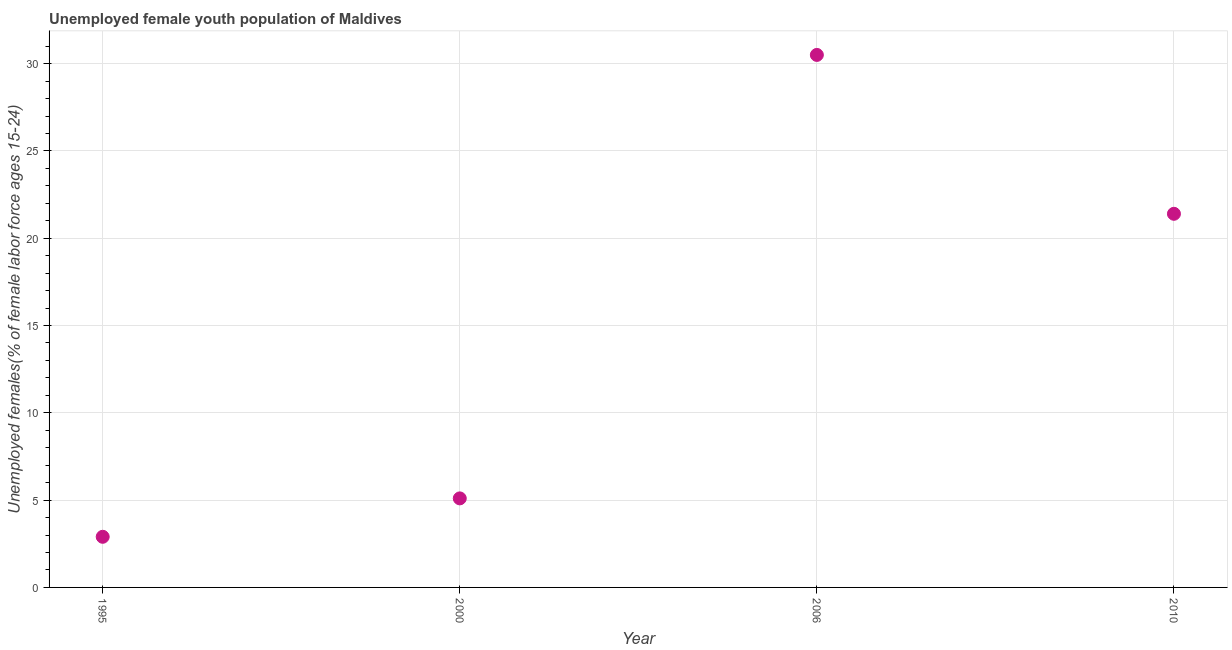What is the unemployed female youth in 2006?
Make the answer very short. 30.5. Across all years, what is the maximum unemployed female youth?
Provide a succinct answer. 30.5. Across all years, what is the minimum unemployed female youth?
Keep it short and to the point. 2.9. In which year was the unemployed female youth minimum?
Your response must be concise. 1995. What is the sum of the unemployed female youth?
Make the answer very short. 59.9. What is the difference between the unemployed female youth in 2006 and 2010?
Give a very brief answer. 9.1. What is the average unemployed female youth per year?
Your response must be concise. 14.97. What is the median unemployed female youth?
Your answer should be very brief. 13.25. Do a majority of the years between 2006 and 2010 (inclusive) have unemployed female youth greater than 2 %?
Provide a succinct answer. Yes. What is the ratio of the unemployed female youth in 1995 to that in 2010?
Offer a terse response. 0.14. Is the unemployed female youth in 1995 less than that in 2010?
Offer a terse response. Yes. Is the difference between the unemployed female youth in 1995 and 2010 greater than the difference between any two years?
Give a very brief answer. No. What is the difference between the highest and the second highest unemployed female youth?
Make the answer very short. 9.1. Is the sum of the unemployed female youth in 1995 and 2000 greater than the maximum unemployed female youth across all years?
Give a very brief answer. No. What is the difference between the highest and the lowest unemployed female youth?
Give a very brief answer. 27.6. Does the unemployed female youth monotonically increase over the years?
Give a very brief answer. No. What is the difference between two consecutive major ticks on the Y-axis?
Make the answer very short. 5. Does the graph contain grids?
Give a very brief answer. Yes. What is the title of the graph?
Your answer should be very brief. Unemployed female youth population of Maldives. What is the label or title of the X-axis?
Ensure brevity in your answer.  Year. What is the label or title of the Y-axis?
Offer a terse response. Unemployed females(% of female labor force ages 15-24). What is the Unemployed females(% of female labor force ages 15-24) in 1995?
Make the answer very short. 2.9. What is the Unemployed females(% of female labor force ages 15-24) in 2000?
Ensure brevity in your answer.  5.1. What is the Unemployed females(% of female labor force ages 15-24) in 2006?
Provide a succinct answer. 30.5. What is the Unemployed females(% of female labor force ages 15-24) in 2010?
Give a very brief answer. 21.4. What is the difference between the Unemployed females(% of female labor force ages 15-24) in 1995 and 2006?
Make the answer very short. -27.6. What is the difference between the Unemployed females(% of female labor force ages 15-24) in 1995 and 2010?
Keep it short and to the point. -18.5. What is the difference between the Unemployed females(% of female labor force ages 15-24) in 2000 and 2006?
Offer a terse response. -25.4. What is the difference between the Unemployed females(% of female labor force ages 15-24) in 2000 and 2010?
Your answer should be compact. -16.3. What is the ratio of the Unemployed females(% of female labor force ages 15-24) in 1995 to that in 2000?
Offer a very short reply. 0.57. What is the ratio of the Unemployed females(% of female labor force ages 15-24) in 1995 to that in 2006?
Provide a succinct answer. 0.1. What is the ratio of the Unemployed females(% of female labor force ages 15-24) in 1995 to that in 2010?
Your answer should be compact. 0.14. What is the ratio of the Unemployed females(% of female labor force ages 15-24) in 2000 to that in 2006?
Offer a very short reply. 0.17. What is the ratio of the Unemployed females(% of female labor force ages 15-24) in 2000 to that in 2010?
Ensure brevity in your answer.  0.24. What is the ratio of the Unemployed females(% of female labor force ages 15-24) in 2006 to that in 2010?
Offer a terse response. 1.43. 